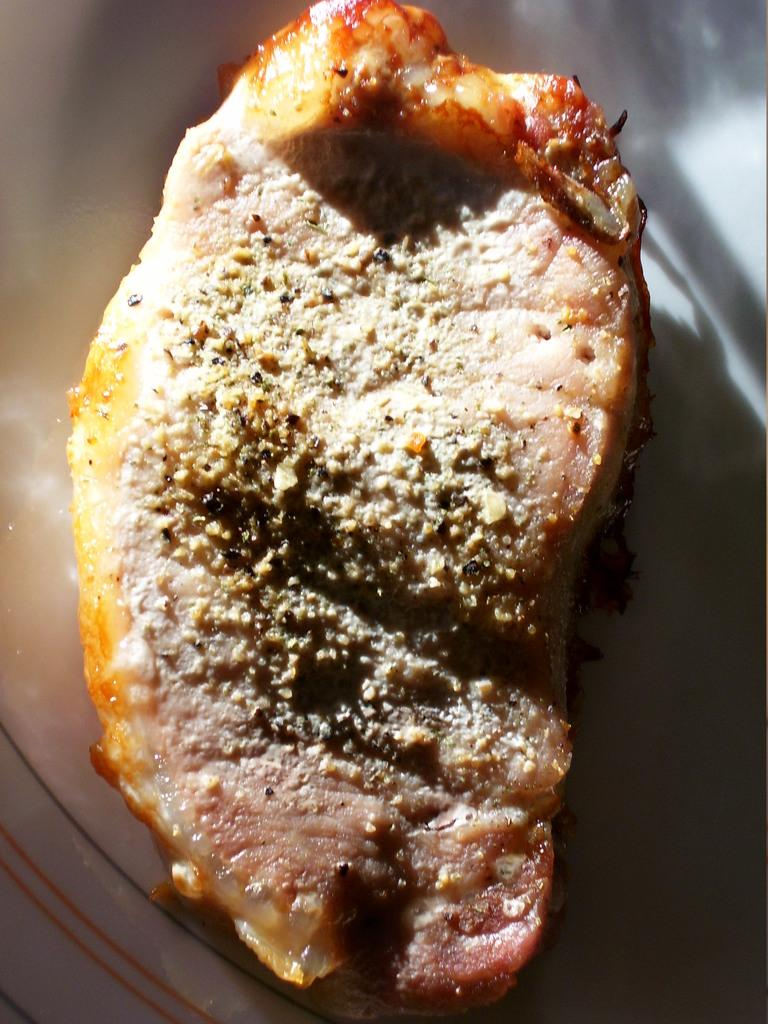What is the main subject of the image? There is a food item in the image. Can you describe the location of the food item? The food item is placed on a surface. How many balls are visible in the image? There are no balls present in the image. What type of bell can be seen ringing in the image? There is no bell present in the image. 